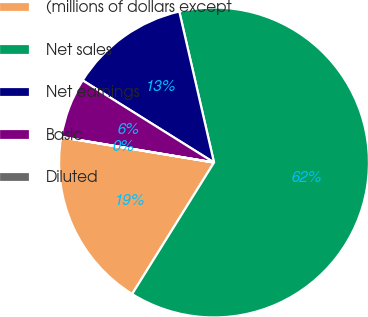Convert chart. <chart><loc_0><loc_0><loc_500><loc_500><pie_chart><fcel>(millions of dollars except<fcel>Net sales<fcel>Net earnings<fcel>Basic<fcel>Diluted<nl><fcel>18.75%<fcel>62.46%<fcel>12.51%<fcel>6.26%<fcel>0.02%<nl></chart> 